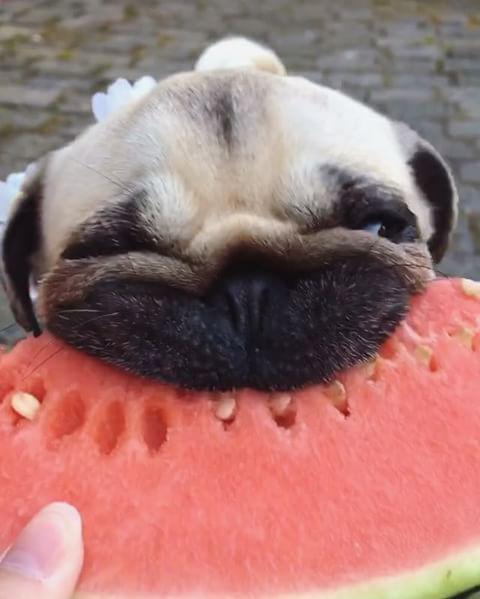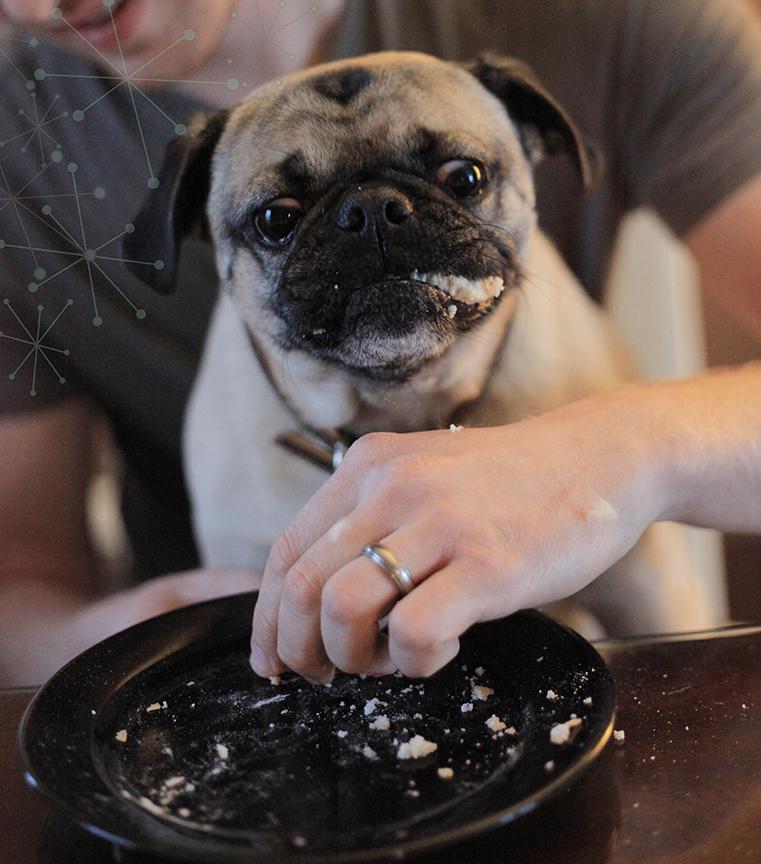The first image is the image on the left, the second image is the image on the right. Examine the images to the left and right. Is the description "An image shows a pug dog chomping on watermelon." accurate? Answer yes or no. Yes. The first image is the image on the left, the second image is the image on the right. For the images shown, is this caption "The dog in the image on the left is eating a chunk of watermelon." true? Answer yes or no. Yes. 